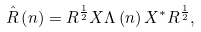<formula> <loc_0><loc_0><loc_500><loc_500>\hat { R } \left ( n \right ) = R ^ { \frac { 1 } { 2 } } X \Lambda \left ( n \right ) X ^ { * } R ^ { \frac { 1 } { 2 } } ,</formula> 